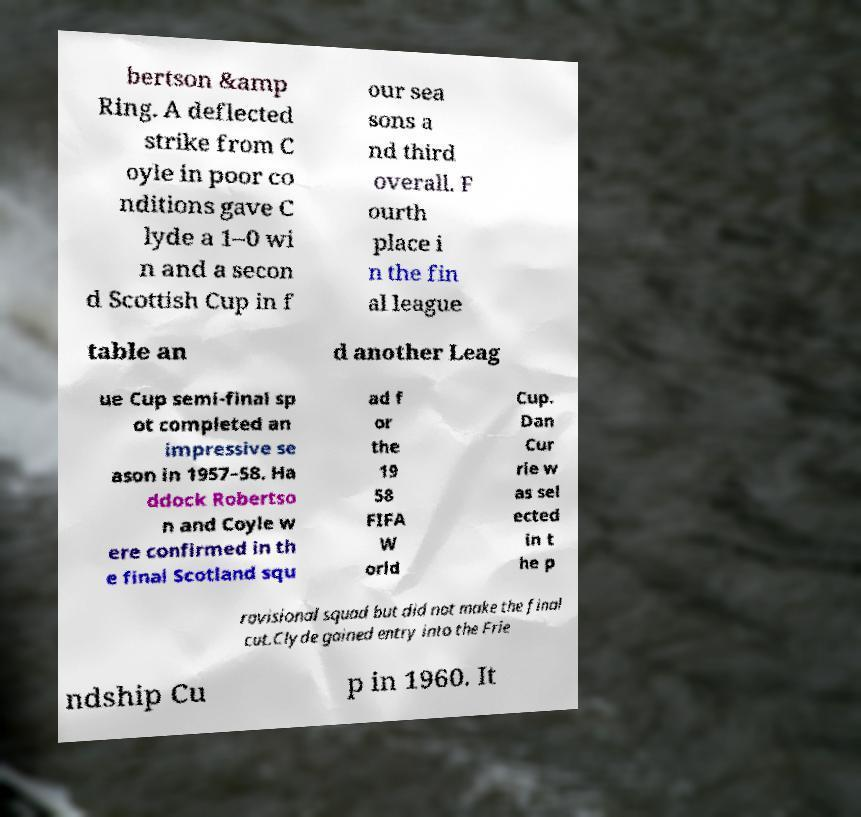I need the written content from this picture converted into text. Can you do that? bertson &amp Ring. A deflected strike from C oyle in poor co nditions gave C lyde a 1–0 wi n and a secon d Scottish Cup in f our sea sons a nd third overall. F ourth place i n the fin al league table an d another Leag ue Cup semi-final sp ot completed an impressive se ason in 1957–58. Ha ddock Robertso n and Coyle w ere confirmed in th e final Scotland squ ad f or the 19 58 FIFA W orld Cup. Dan Cur rie w as sel ected in t he p rovisional squad but did not make the final cut.Clyde gained entry into the Frie ndship Cu p in 1960. It 